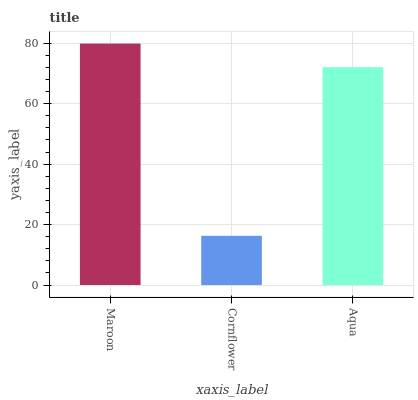Is Aqua the minimum?
Answer yes or no. No. Is Aqua the maximum?
Answer yes or no. No. Is Aqua greater than Cornflower?
Answer yes or no. Yes. Is Cornflower less than Aqua?
Answer yes or no. Yes. Is Cornflower greater than Aqua?
Answer yes or no. No. Is Aqua less than Cornflower?
Answer yes or no. No. Is Aqua the high median?
Answer yes or no. Yes. Is Aqua the low median?
Answer yes or no. Yes. Is Cornflower the high median?
Answer yes or no. No. Is Cornflower the low median?
Answer yes or no. No. 